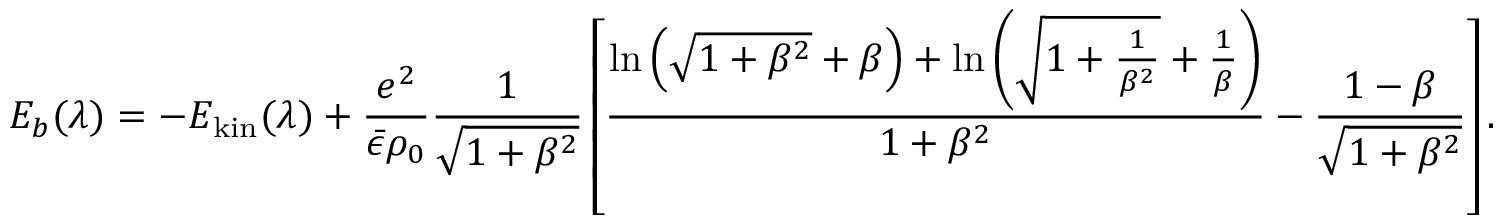<formula> <loc_0><loc_0><loc_500><loc_500>E _ { b } ( \lambda ) = - E _ { k i n } ( \lambda ) + \frac { e ^ { 2 } } { \bar { \epsilon } \rho _ { 0 } } \frac { 1 } { \sqrt { 1 + \beta ^ { 2 } } } \left [ \frac { \ln \left ( \sqrt { 1 + \beta ^ { 2 } } + \beta \right ) + \ln \left ( \sqrt { 1 + \frac { 1 } { \beta ^ { 2 } } } + \frac { 1 } { \beta } \right ) } { 1 + \beta ^ { 2 } } - \frac { 1 - \beta } { \sqrt { 1 + \beta ^ { 2 } } } \right ] .</formula> 